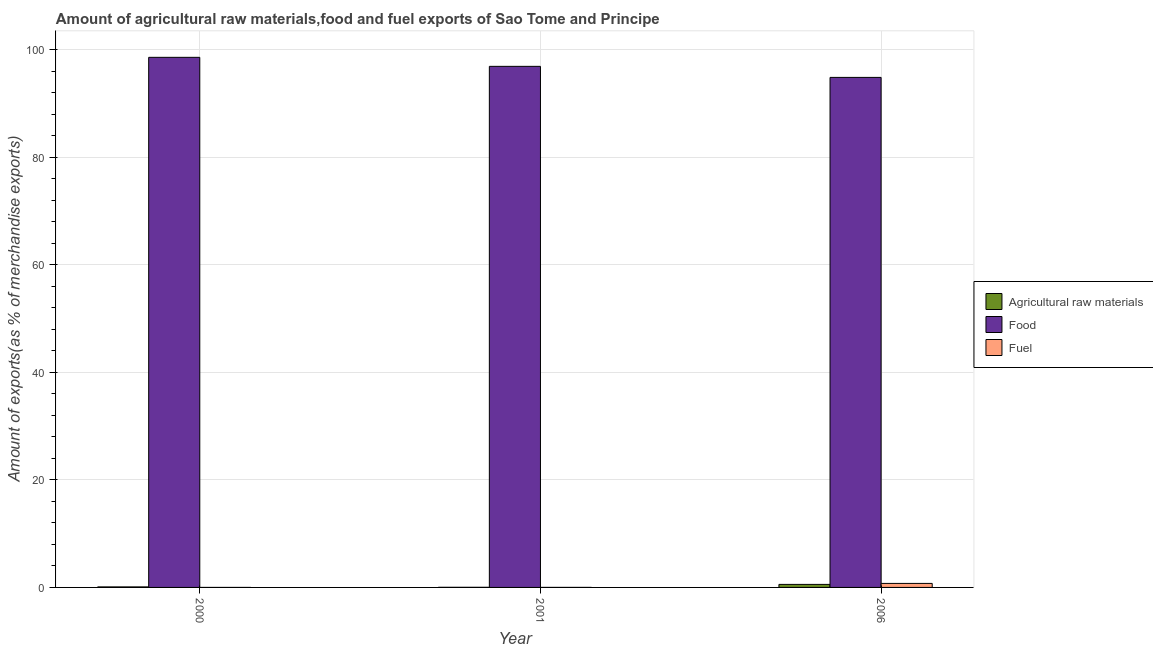How many groups of bars are there?
Provide a succinct answer. 3. Are the number of bars on each tick of the X-axis equal?
Your answer should be very brief. Yes. What is the label of the 2nd group of bars from the left?
Offer a terse response. 2001. What is the percentage of raw materials exports in 2000?
Give a very brief answer. 0.1. Across all years, what is the maximum percentage of raw materials exports?
Offer a very short reply. 0.56. Across all years, what is the minimum percentage of raw materials exports?
Provide a succinct answer. 0.02. In which year was the percentage of raw materials exports maximum?
Your answer should be compact. 2006. What is the total percentage of raw materials exports in the graph?
Make the answer very short. 0.68. What is the difference between the percentage of fuel exports in 2000 and that in 2001?
Make the answer very short. -0.01. What is the difference between the percentage of food exports in 2000 and the percentage of raw materials exports in 2001?
Keep it short and to the point. 1.68. What is the average percentage of raw materials exports per year?
Ensure brevity in your answer.  0.23. In how many years, is the percentage of food exports greater than 52 %?
Provide a succinct answer. 3. What is the ratio of the percentage of raw materials exports in 2000 to that in 2006?
Offer a very short reply. 0.17. Is the percentage of raw materials exports in 2000 less than that in 2006?
Ensure brevity in your answer.  Yes. Is the difference between the percentage of fuel exports in 2000 and 2001 greater than the difference between the percentage of food exports in 2000 and 2001?
Offer a very short reply. No. What is the difference between the highest and the second highest percentage of raw materials exports?
Your answer should be very brief. 0.47. What is the difference between the highest and the lowest percentage of fuel exports?
Your answer should be very brief. 0.75. Is the sum of the percentage of raw materials exports in 2000 and 2001 greater than the maximum percentage of food exports across all years?
Provide a short and direct response. No. What does the 3rd bar from the left in 2006 represents?
Ensure brevity in your answer.  Fuel. What does the 1st bar from the right in 2006 represents?
Make the answer very short. Fuel. Is it the case that in every year, the sum of the percentage of raw materials exports and percentage of food exports is greater than the percentage of fuel exports?
Your response must be concise. Yes. Are all the bars in the graph horizontal?
Offer a very short reply. No. How many years are there in the graph?
Offer a very short reply. 3. What is the difference between two consecutive major ticks on the Y-axis?
Provide a succinct answer. 20. Does the graph contain grids?
Your answer should be compact. Yes. Where does the legend appear in the graph?
Your response must be concise. Center right. How are the legend labels stacked?
Offer a very short reply. Vertical. What is the title of the graph?
Your answer should be very brief. Amount of agricultural raw materials,food and fuel exports of Sao Tome and Principe. What is the label or title of the Y-axis?
Give a very brief answer. Amount of exports(as % of merchandise exports). What is the Amount of exports(as % of merchandise exports) of Agricultural raw materials in 2000?
Your response must be concise. 0.1. What is the Amount of exports(as % of merchandise exports) of Food in 2000?
Provide a succinct answer. 98.6. What is the Amount of exports(as % of merchandise exports) of Fuel in 2000?
Make the answer very short. 0. What is the Amount of exports(as % of merchandise exports) in Agricultural raw materials in 2001?
Make the answer very short. 0.02. What is the Amount of exports(as % of merchandise exports) in Food in 2001?
Make the answer very short. 96.92. What is the Amount of exports(as % of merchandise exports) in Fuel in 2001?
Offer a very short reply. 0.01. What is the Amount of exports(as % of merchandise exports) in Agricultural raw materials in 2006?
Your answer should be compact. 0.56. What is the Amount of exports(as % of merchandise exports) in Food in 2006?
Provide a succinct answer. 94.87. What is the Amount of exports(as % of merchandise exports) in Fuel in 2006?
Your response must be concise. 0.75. Across all years, what is the maximum Amount of exports(as % of merchandise exports) in Agricultural raw materials?
Offer a very short reply. 0.56. Across all years, what is the maximum Amount of exports(as % of merchandise exports) in Food?
Make the answer very short. 98.6. Across all years, what is the maximum Amount of exports(as % of merchandise exports) of Fuel?
Keep it short and to the point. 0.75. Across all years, what is the minimum Amount of exports(as % of merchandise exports) of Agricultural raw materials?
Your answer should be compact. 0.02. Across all years, what is the minimum Amount of exports(as % of merchandise exports) in Food?
Your response must be concise. 94.87. Across all years, what is the minimum Amount of exports(as % of merchandise exports) of Fuel?
Make the answer very short. 0. What is the total Amount of exports(as % of merchandise exports) of Agricultural raw materials in the graph?
Your response must be concise. 0.68. What is the total Amount of exports(as % of merchandise exports) of Food in the graph?
Ensure brevity in your answer.  290.39. What is the total Amount of exports(as % of merchandise exports) in Fuel in the graph?
Provide a succinct answer. 0.75. What is the difference between the Amount of exports(as % of merchandise exports) in Agricultural raw materials in 2000 and that in 2001?
Ensure brevity in your answer.  0.07. What is the difference between the Amount of exports(as % of merchandise exports) in Food in 2000 and that in 2001?
Offer a terse response. 1.68. What is the difference between the Amount of exports(as % of merchandise exports) of Fuel in 2000 and that in 2001?
Offer a terse response. -0.01. What is the difference between the Amount of exports(as % of merchandise exports) of Agricultural raw materials in 2000 and that in 2006?
Provide a short and direct response. -0.47. What is the difference between the Amount of exports(as % of merchandise exports) in Food in 2000 and that in 2006?
Ensure brevity in your answer.  3.73. What is the difference between the Amount of exports(as % of merchandise exports) of Fuel in 2000 and that in 2006?
Your answer should be compact. -0.75. What is the difference between the Amount of exports(as % of merchandise exports) of Agricultural raw materials in 2001 and that in 2006?
Offer a terse response. -0.54. What is the difference between the Amount of exports(as % of merchandise exports) in Food in 2001 and that in 2006?
Your answer should be very brief. 2.05. What is the difference between the Amount of exports(as % of merchandise exports) in Fuel in 2001 and that in 2006?
Make the answer very short. -0.74. What is the difference between the Amount of exports(as % of merchandise exports) in Agricultural raw materials in 2000 and the Amount of exports(as % of merchandise exports) in Food in 2001?
Your response must be concise. -96.82. What is the difference between the Amount of exports(as % of merchandise exports) in Agricultural raw materials in 2000 and the Amount of exports(as % of merchandise exports) in Fuel in 2001?
Provide a short and direct response. 0.09. What is the difference between the Amount of exports(as % of merchandise exports) of Food in 2000 and the Amount of exports(as % of merchandise exports) of Fuel in 2001?
Offer a terse response. 98.59. What is the difference between the Amount of exports(as % of merchandise exports) of Agricultural raw materials in 2000 and the Amount of exports(as % of merchandise exports) of Food in 2006?
Give a very brief answer. -94.77. What is the difference between the Amount of exports(as % of merchandise exports) of Agricultural raw materials in 2000 and the Amount of exports(as % of merchandise exports) of Fuel in 2006?
Ensure brevity in your answer.  -0.65. What is the difference between the Amount of exports(as % of merchandise exports) of Food in 2000 and the Amount of exports(as % of merchandise exports) of Fuel in 2006?
Give a very brief answer. 97.85. What is the difference between the Amount of exports(as % of merchandise exports) of Agricultural raw materials in 2001 and the Amount of exports(as % of merchandise exports) of Food in 2006?
Provide a succinct answer. -94.84. What is the difference between the Amount of exports(as % of merchandise exports) in Agricultural raw materials in 2001 and the Amount of exports(as % of merchandise exports) in Fuel in 2006?
Give a very brief answer. -0.72. What is the difference between the Amount of exports(as % of merchandise exports) in Food in 2001 and the Amount of exports(as % of merchandise exports) in Fuel in 2006?
Give a very brief answer. 96.17. What is the average Amount of exports(as % of merchandise exports) of Agricultural raw materials per year?
Your answer should be very brief. 0.23. What is the average Amount of exports(as % of merchandise exports) of Food per year?
Provide a succinct answer. 96.8. What is the average Amount of exports(as % of merchandise exports) of Fuel per year?
Keep it short and to the point. 0.25. In the year 2000, what is the difference between the Amount of exports(as % of merchandise exports) of Agricultural raw materials and Amount of exports(as % of merchandise exports) of Food?
Offer a very short reply. -98.5. In the year 2000, what is the difference between the Amount of exports(as % of merchandise exports) of Agricultural raw materials and Amount of exports(as % of merchandise exports) of Fuel?
Keep it short and to the point. 0.1. In the year 2000, what is the difference between the Amount of exports(as % of merchandise exports) of Food and Amount of exports(as % of merchandise exports) of Fuel?
Your response must be concise. 98.6. In the year 2001, what is the difference between the Amount of exports(as % of merchandise exports) of Agricultural raw materials and Amount of exports(as % of merchandise exports) of Food?
Keep it short and to the point. -96.9. In the year 2001, what is the difference between the Amount of exports(as % of merchandise exports) in Agricultural raw materials and Amount of exports(as % of merchandise exports) in Fuel?
Offer a terse response. 0.02. In the year 2001, what is the difference between the Amount of exports(as % of merchandise exports) in Food and Amount of exports(as % of merchandise exports) in Fuel?
Your answer should be very brief. 96.92. In the year 2006, what is the difference between the Amount of exports(as % of merchandise exports) in Agricultural raw materials and Amount of exports(as % of merchandise exports) in Food?
Your answer should be compact. -94.31. In the year 2006, what is the difference between the Amount of exports(as % of merchandise exports) in Agricultural raw materials and Amount of exports(as % of merchandise exports) in Fuel?
Offer a terse response. -0.18. In the year 2006, what is the difference between the Amount of exports(as % of merchandise exports) of Food and Amount of exports(as % of merchandise exports) of Fuel?
Provide a short and direct response. 94.12. What is the ratio of the Amount of exports(as % of merchandise exports) in Agricultural raw materials in 2000 to that in 2001?
Your answer should be compact. 4.28. What is the ratio of the Amount of exports(as % of merchandise exports) of Food in 2000 to that in 2001?
Keep it short and to the point. 1.02. What is the ratio of the Amount of exports(as % of merchandise exports) in Fuel in 2000 to that in 2001?
Your answer should be very brief. 0.02. What is the ratio of the Amount of exports(as % of merchandise exports) of Agricultural raw materials in 2000 to that in 2006?
Ensure brevity in your answer.  0.17. What is the ratio of the Amount of exports(as % of merchandise exports) of Food in 2000 to that in 2006?
Make the answer very short. 1.04. What is the ratio of the Amount of exports(as % of merchandise exports) of Agricultural raw materials in 2001 to that in 2006?
Make the answer very short. 0.04. What is the ratio of the Amount of exports(as % of merchandise exports) of Food in 2001 to that in 2006?
Offer a very short reply. 1.02. What is the ratio of the Amount of exports(as % of merchandise exports) in Fuel in 2001 to that in 2006?
Your answer should be very brief. 0.01. What is the difference between the highest and the second highest Amount of exports(as % of merchandise exports) in Agricultural raw materials?
Make the answer very short. 0.47. What is the difference between the highest and the second highest Amount of exports(as % of merchandise exports) of Food?
Ensure brevity in your answer.  1.68. What is the difference between the highest and the second highest Amount of exports(as % of merchandise exports) in Fuel?
Your answer should be compact. 0.74. What is the difference between the highest and the lowest Amount of exports(as % of merchandise exports) of Agricultural raw materials?
Offer a very short reply. 0.54. What is the difference between the highest and the lowest Amount of exports(as % of merchandise exports) of Food?
Offer a very short reply. 3.73. What is the difference between the highest and the lowest Amount of exports(as % of merchandise exports) in Fuel?
Your answer should be very brief. 0.75. 